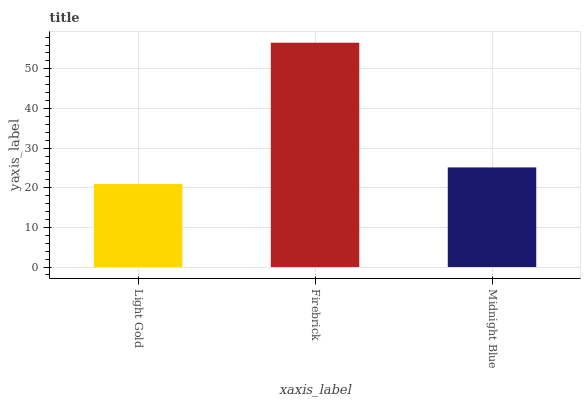Is Light Gold the minimum?
Answer yes or no. Yes. Is Firebrick the maximum?
Answer yes or no. Yes. Is Midnight Blue the minimum?
Answer yes or no. No. Is Midnight Blue the maximum?
Answer yes or no. No. Is Firebrick greater than Midnight Blue?
Answer yes or no. Yes. Is Midnight Blue less than Firebrick?
Answer yes or no. Yes. Is Midnight Blue greater than Firebrick?
Answer yes or no. No. Is Firebrick less than Midnight Blue?
Answer yes or no. No. Is Midnight Blue the high median?
Answer yes or no. Yes. Is Midnight Blue the low median?
Answer yes or no. Yes. Is Light Gold the high median?
Answer yes or no. No. Is Firebrick the low median?
Answer yes or no. No. 